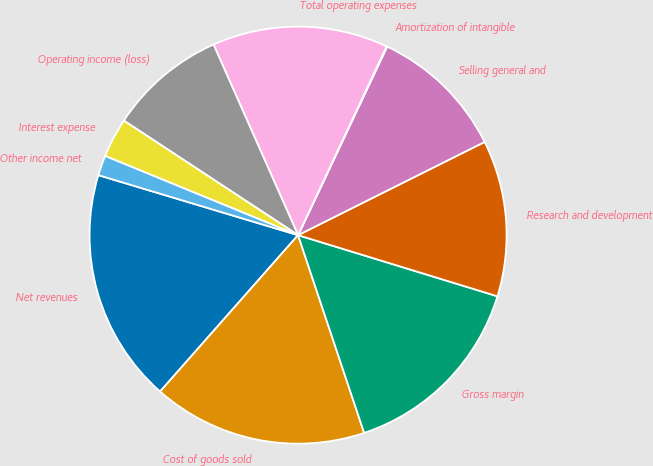<chart> <loc_0><loc_0><loc_500><loc_500><pie_chart><fcel>Net revenues<fcel>Cost of goods sold<fcel>Gross margin<fcel>Research and development<fcel>Selling general and<fcel>Amortization of intangible<fcel>Total operating expenses<fcel>Operating income (loss)<fcel>Interest expense<fcel>Other income net<nl><fcel>18.14%<fcel>16.64%<fcel>15.13%<fcel>12.11%<fcel>10.6%<fcel>0.05%<fcel>13.62%<fcel>9.1%<fcel>3.06%<fcel>1.55%<nl></chart> 